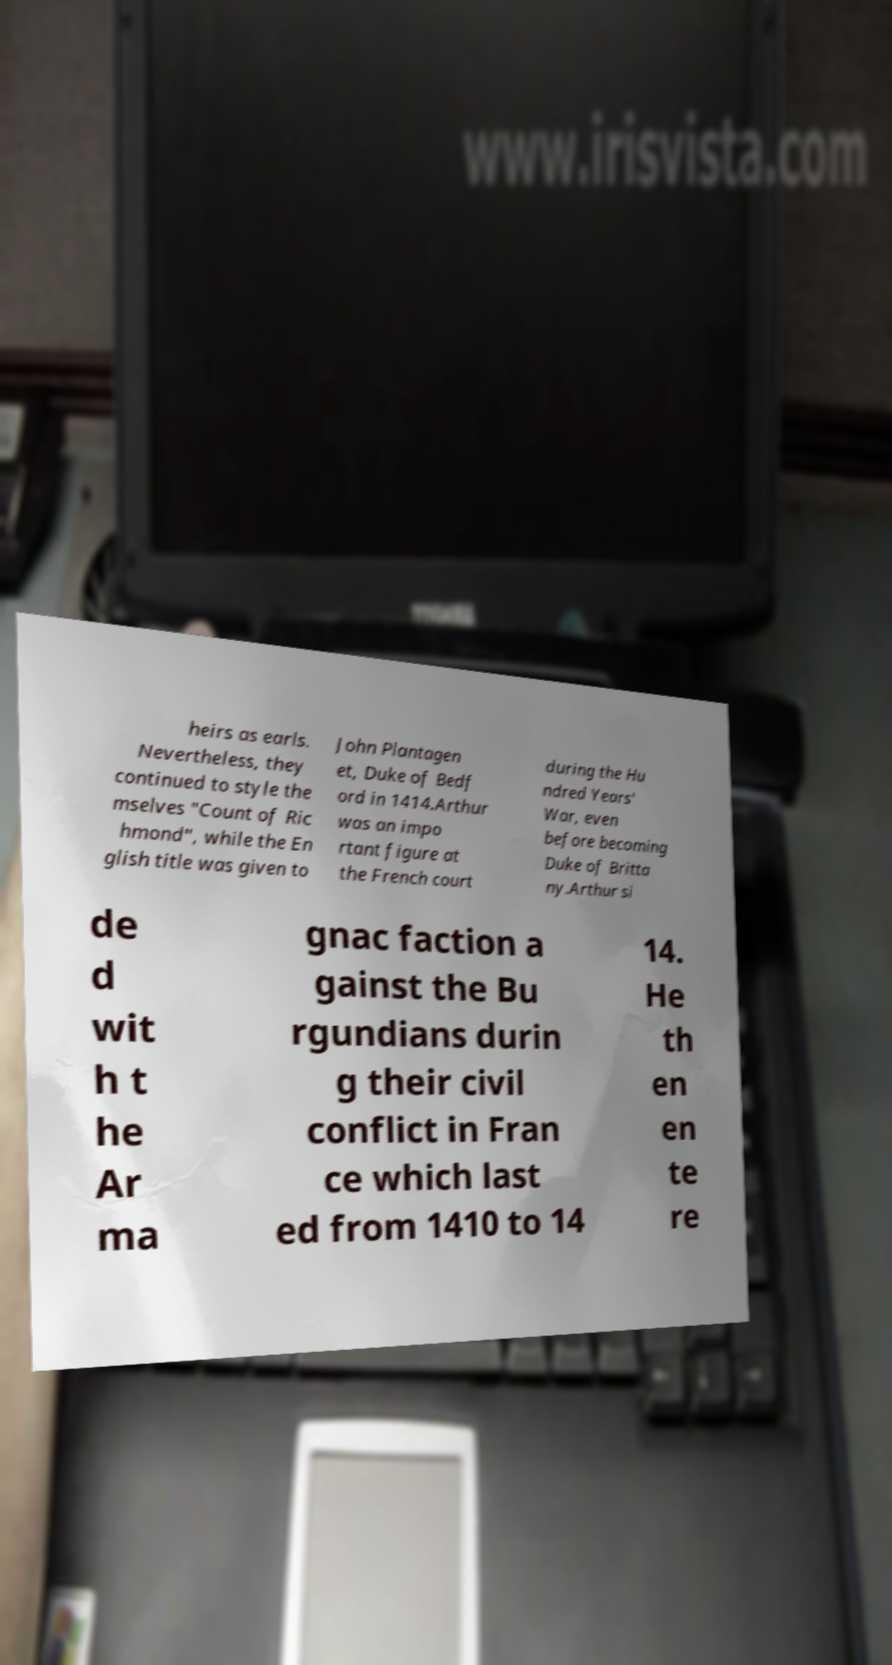Please read and relay the text visible in this image. What does it say? heirs as earls. Nevertheless, they continued to style the mselves "Count of Ric hmond", while the En glish title was given to John Plantagen et, Duke of Bedf ord in 1414.Arthur was an impo rtant figure at the French court during the Hu ndred Years' War, even before becoming Duke of Britta ny.Arthur si de d wit h t he Ar ma gnac faction a gainst the Bu rgundians durin g their civil conflict in Fran ce which last ed from 1410 to 14 14. He th en en te re 